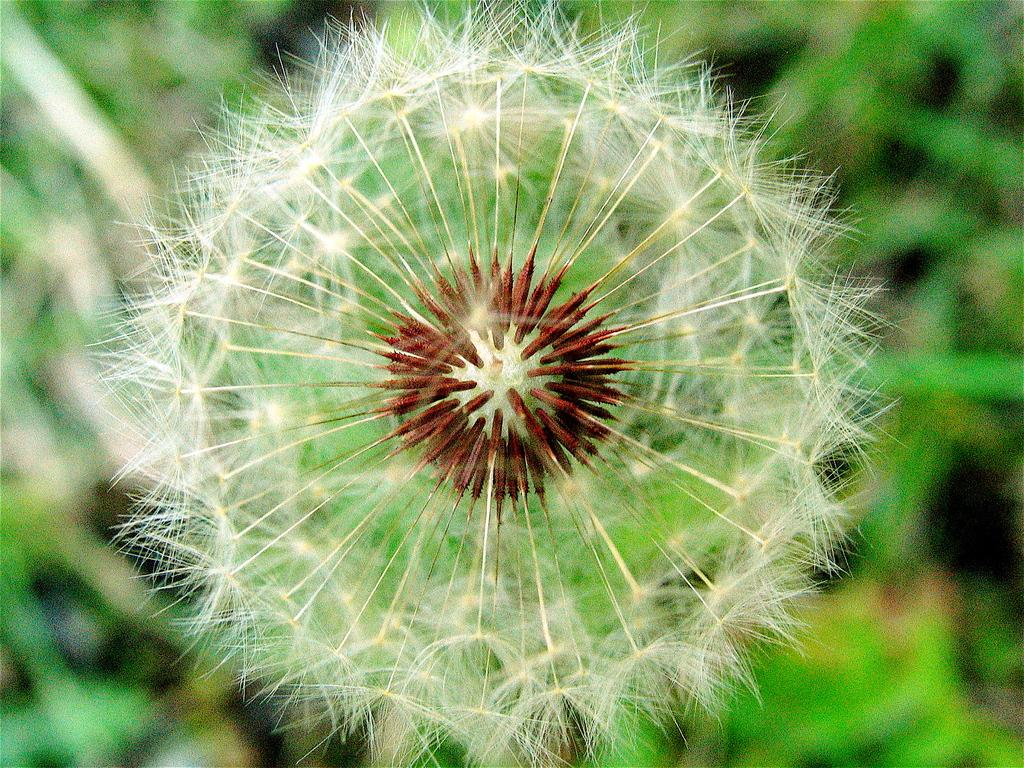What is the main subject of the image? There is a flower in the image. How would you describe the background of the image? The background of the image is blurred. What type of natural environment can be seen in the background? There is greenery visible in the background of the image. How many balloons are being held by the flower in the image? There are no balloons present in the image; it features a flower and a blurred background. Who is the representative of the flower in the image? The concept of a representative does not apply to a flower in an image, as flowers are not sentient beings capable of representation. 